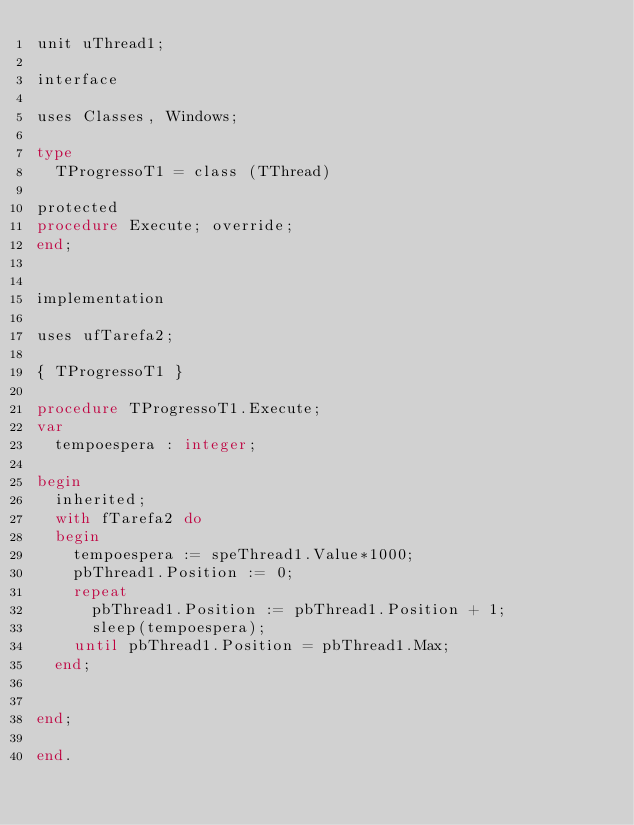Convert code to text. <code><loc_0><loc_0><loc_500><loc_500><_Pascal_>unit uThread1;

interface

uses Classes, Windows;

type
  TProgressoT1 = class (TThread)

protected
procedure Execute; override;
end;


implementation

uses ufTarefa2;

{ TProgressoT1 }

procedure TProgressoT1.Execute;
var
  tempoespera : integer;

begin
  inherited;
  with fTarefa2 do
  begin
    tempoespera := speThread1.Value*1000;
    pbThread1.Position := 0;
    repeat
      pbThread1.Position := pbThread1.Position + 1;
      sleep(tempoespera);
    until pbThread1.Position = pbThread1.Max;
  end;


end;

end.
</code> 